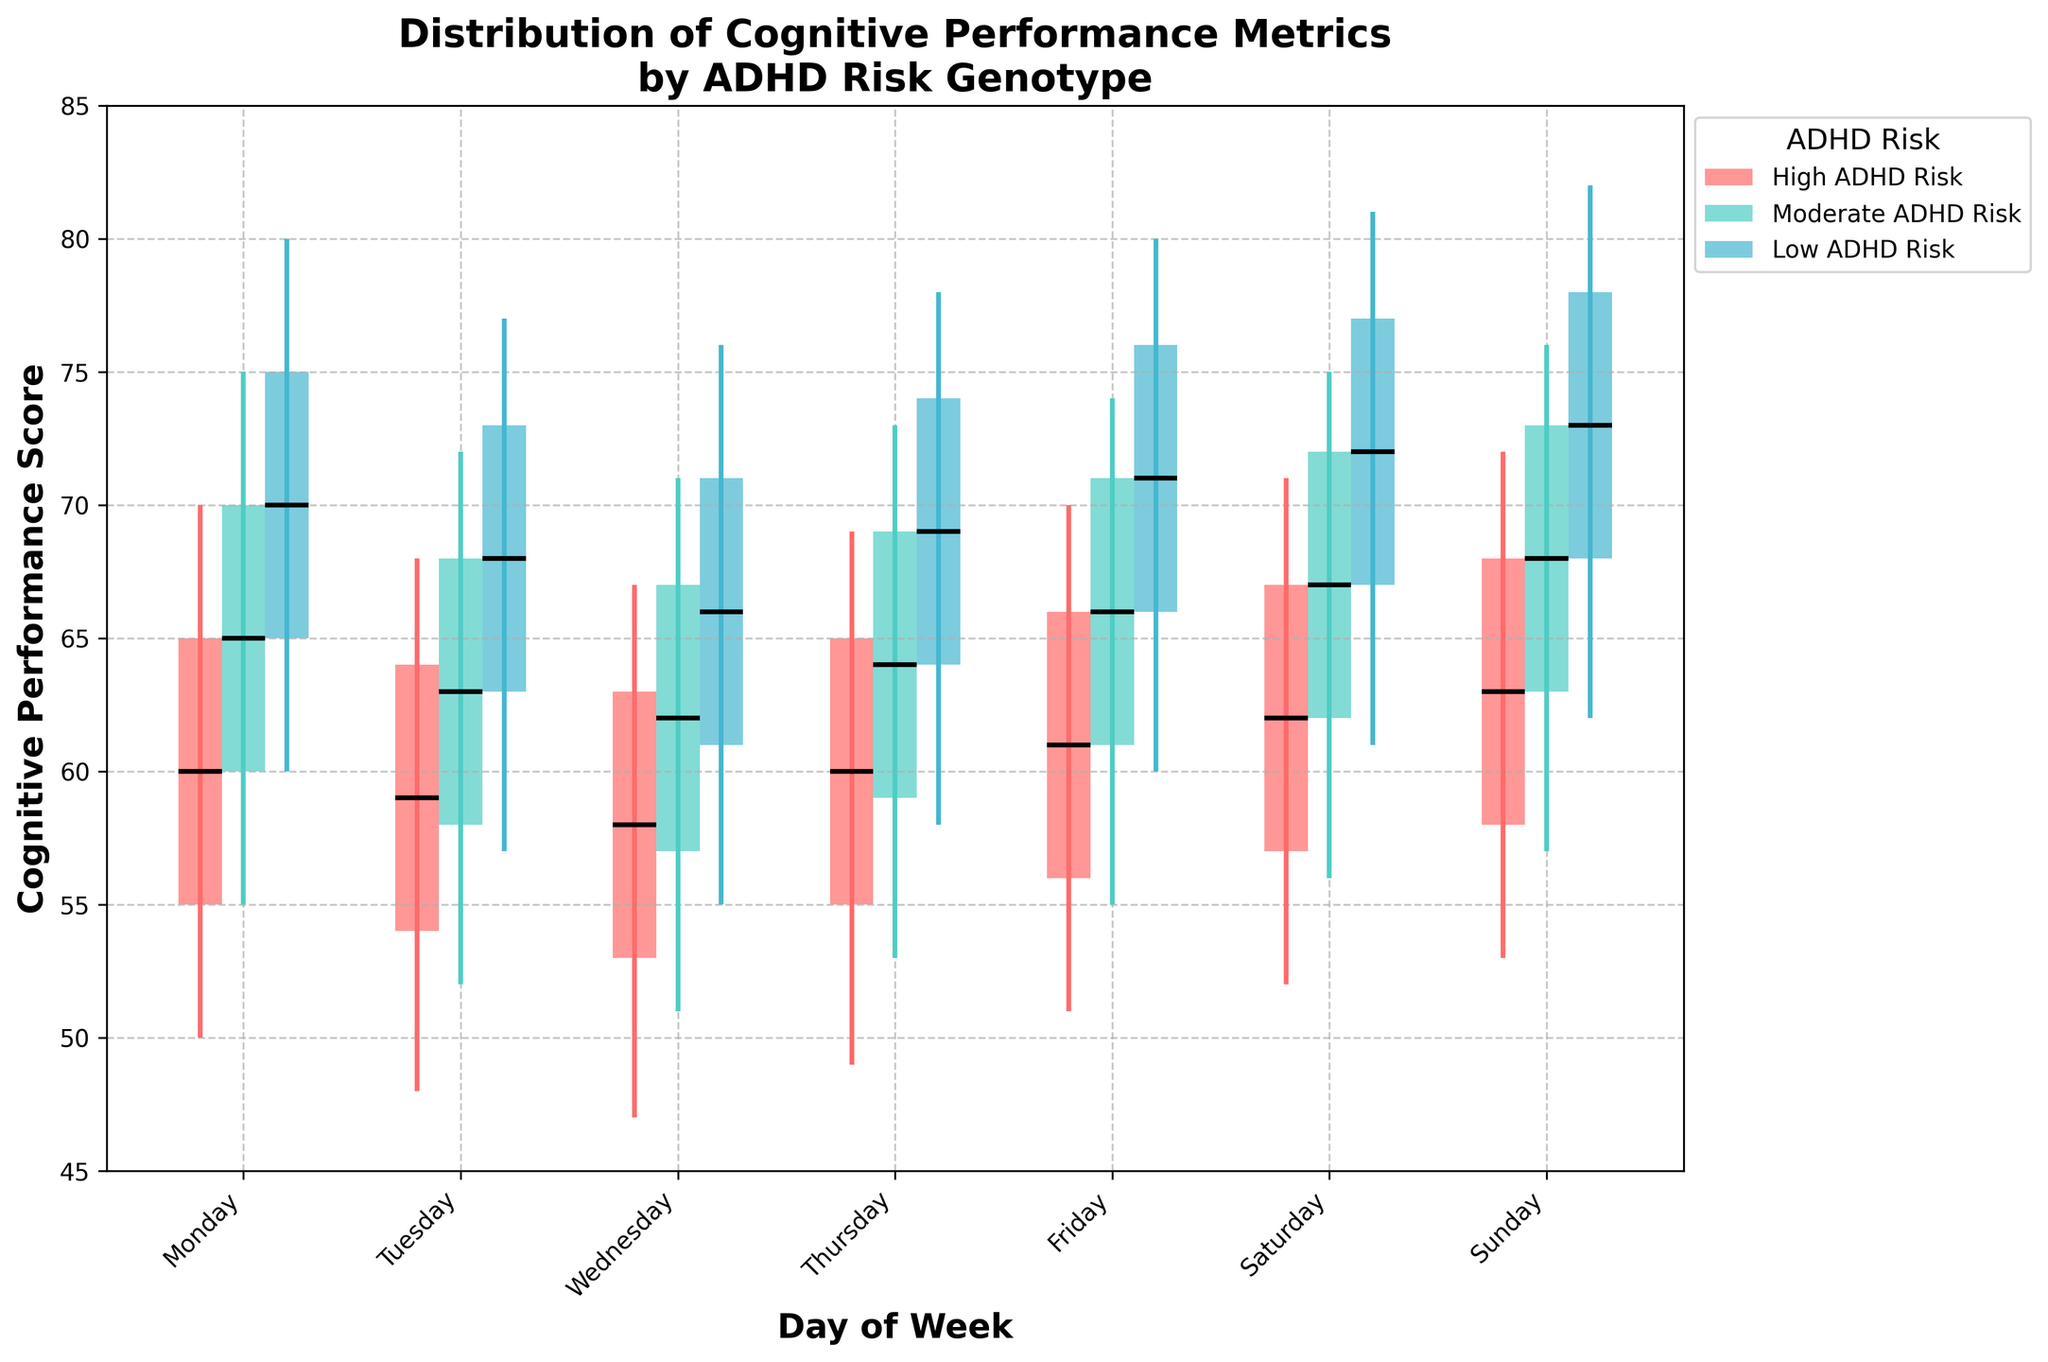What's the title of the figure? To determine the title, look at the text displayed prominently at the top of the figure. The title is usually descriptive of the data being presented.
Answer: Distribution of Cognitive Performance Metrics by ADHD Risk Genotype What is displayed on the X-axis of the figure? The X-axis provides labels that categorize each data point. In this case, observe the text labels at the bottom of the figure.
Answer: Day of Week What cognitive performance metric does the Y-axis represent? To find out what the Y-axis represents, look at the label of the Y-axis on the left side of the plot.
Answer: Cognitive Performance Score Which genotype shows the lowest median cognitive performance on Wednesday? Look at the horizontal lines inside the boxes for each genotype on Wednesday; the median is represented by these lines. Identify the genotype with the lowest line.
Answer: High ADHD Risk How does the range of cognitive performance scores for 'Low ADHD Risk' individuals on Sunday compare to those on Monday? Examine the vertical lines (whiskers) for 'Low ADHD Risk' individuals on both days. Compare the minimum and maximum values.
Answer: Both Sunday (Min: 62, Max: 82) and Monday (Min: 60, Max: 80) have similar ranges, with Sunday having a slightly higher range Which day shows the smallest interquartile range (IQR) for individuals with 'Moderate ADHD Risk'? The IQR is the height of the box. Compare the height of boxes for 'Moderate ADHD Risk' across all days and identify the smallest one.
Answer: Tuesday On which day is the maximum cognitive performance score for 'High ADHD Risk' highest? Compare the top ends of the whiskers for 'High ADHD Risk' across all days to find the highest point.
Answer: Sunday What is the difference between the median cognitive performance scores for 'Moderate ADHD Risk' and 'Low ADHD Risk' on Friday? Locate the median lines within the 'Moderate ADHD Risk' and 'Low ADHD Risk' boxes on Friday. Subtract the 'Moderate ADHD Risk' median from the 'Low ADHD Risk' median.
Answer: 5 (Low ADHD Risk: 71, Moderate ADHD Risk: 66) How does the median vary over the days of the week for individuals with 'High ADHD Risk'? Analyze the position of the median line within 'High ADHD Risk' boxes from Monday to Sunday. Observe changes in height across the days.
Answer: The median slightly decreases from Monday (60) to Wednesday (58) and then gradually increases towards Sunday (63) 